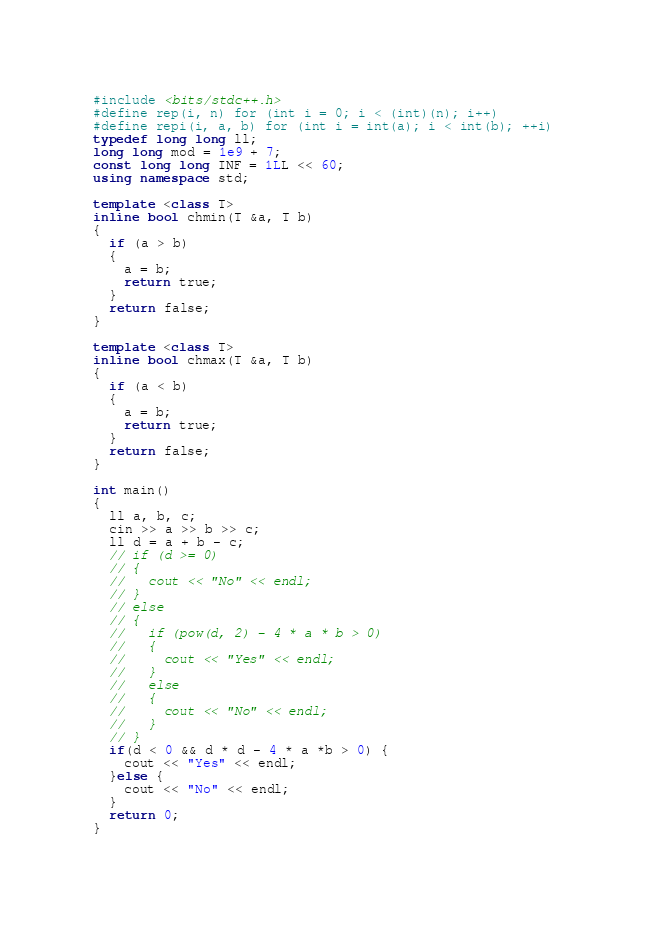Convert code to text. <code><loc_0><loc_0><loc_500><loc_500><_C++_>#include <bits/stdc++.h>
#define rep(i, n) for (int i = 0; i < (int)(n); i++)
#define repi(i, a, b) for (int i = int(a); i < int(b); ++i)
typedef long long ll;
long long mod = 1e9 + 7;
const long long INF = 1LL << 60;
using namespace std;

template <class T>
inline bool chmin(T &a, T b)
{
  if (a > b)
  {
    a = b;
    return true;
  }
  return false;
}

template <class T>
inline bool chmax(T &a, T b)
{
  if (a < b)
  {
    a = b;
    return true;
  }
  return false;
}

int main()
{
  ll a, b, c;
  cin >> a >> b >> c;
  ll d = a + b - c;
  // if (d >= 0)
  // {
  //   cout << "No" << endl;
  // }
  // else
  // {
  //   if (pow(d, 2) - 4 * a * b > 0)
  //   {
  //     cout << "Yes" << endl;
  //   }
  //   else
  //   {
  //     cout << "No" << endl;
  //   }
  // }
  if(d < 0 && d * d - 4 * a *b > 0) {
    cout << "Yes" << endl;
  }else {
    cout << "No" << endl;
  }
  return 0;
}</code> 